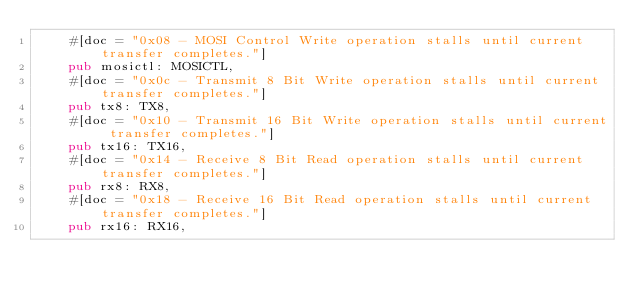<code> <loc_0><loc_0><loc_500><loc_500><_Rust_>    #[doc = "0x08 - MOSI Control Write operation stalls until current transfer completes."]
    pub mosictl: MOSICTL,
    #[doc = "0x0c - Transmit 8 Bit Write operation stalls until current transfer completes."]
    pub tx8: TX8,
    #[doc = "0x10 - Transmit 16 Bit Write operation stalls until current transfer completes."]
    pub tx16: TX16,
    #[doc = "0x14 - Receive 8 Bit Read operation stalls until current transfer completes."]
    pub rx8: RX8,
    #[doc = "0x18 - Receive 16 Bit Read operation stalls until current transfer completes."]
    pub rx16: RX16,</code> 